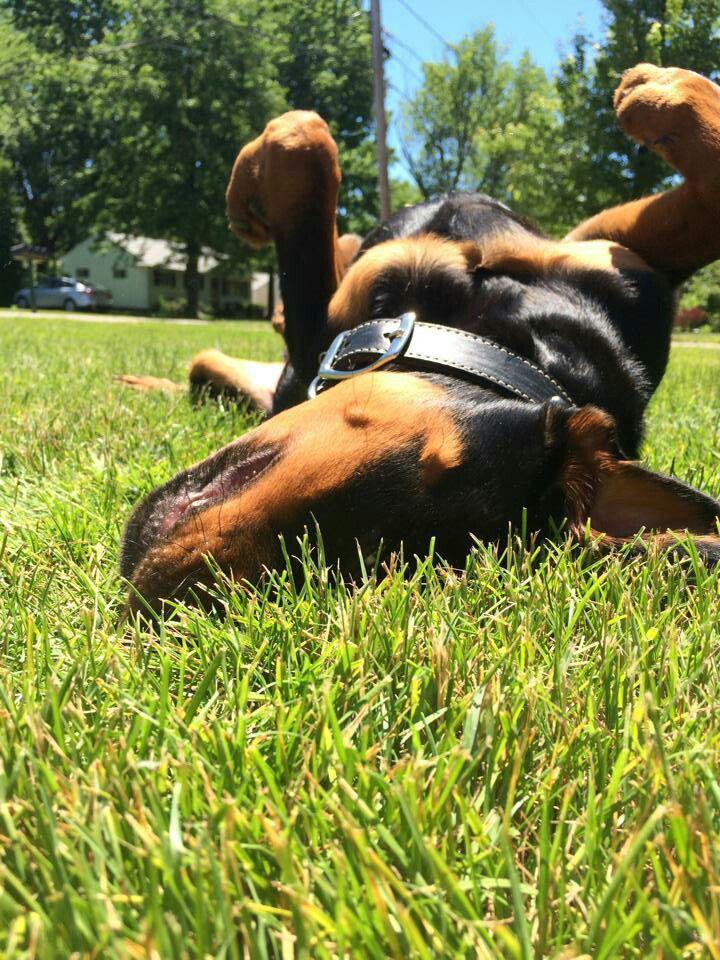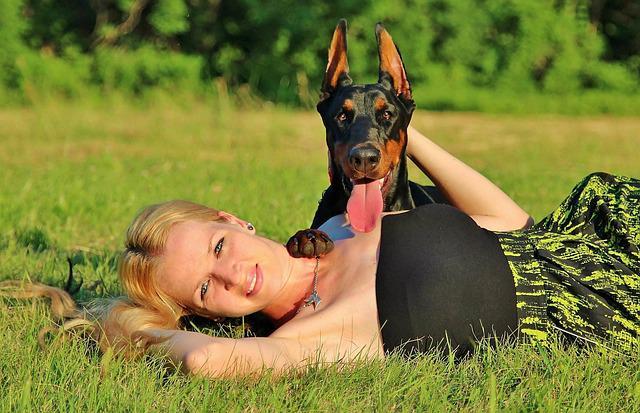The first image is the image on the left, the second image is the image on the right. For the images displayed, is the sentence "The left and right image contains the same number of dogs." factually correct? Answer yes or no. Yes. The first image is the image on the left, the second image is the image on the right. Given the left and right images, does the statement "The left image shows an open-mouthed doberman reclining on the grass by a young 'creature' of some type." hold true? Answer yes or no. No. 